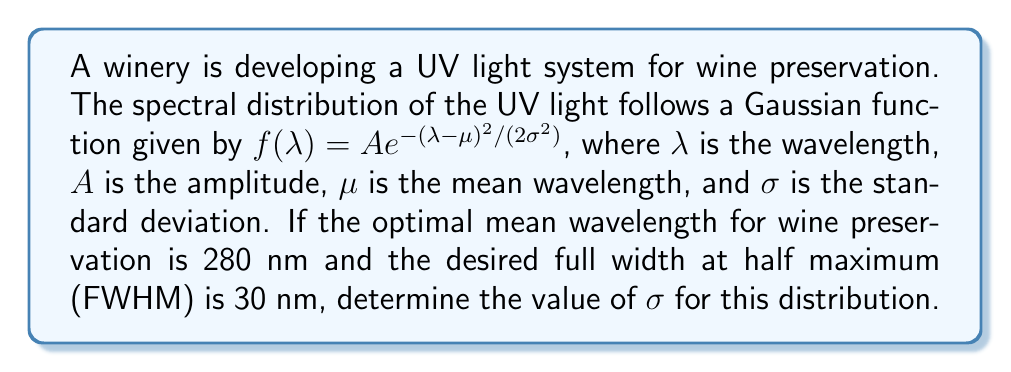Help me with this question. To solve this problem, we'll follow these steps:

1) The FWHM of a Gaussian distribution is related to $\sigma$ by the formula:

   $$FWHM = 2\sqrt{2\ln(2)} \sigma$$

2) We're given that FWHM = 30 nm, so we can substitute this:

   $$30 = 2\sqrt{2\ln(2)} \sigma$$

3) Now, let's solve for $\sigma$:

   $$\sigma = \frac{30}{2\sqrt{2\ln(2)}}$$

4) Calculate the value under the square root:
   
   $$2\ln(2) \approx 1.3862943611198906$$

5) Take the square root:

   $$\sqrt{2\ln(2)} \approx 1.1774100225154747$$

6) Complete the calculation:

   $$\sigma = \frac{30}{2(1.1774100225154747)} \approx 12.7408$$

7) Round to two decimal places for practicality in wine preservation applications:

   $$\sigma \approx 12.74 \text{ nm}$$

This value of $\sigma$ will produce a Gaussian distribution with the desired FWHM of 30 nm, centered at the optimal wavelength of 280 nm for wine preservation.
Answer: $12.74 \text{ nm}$ 